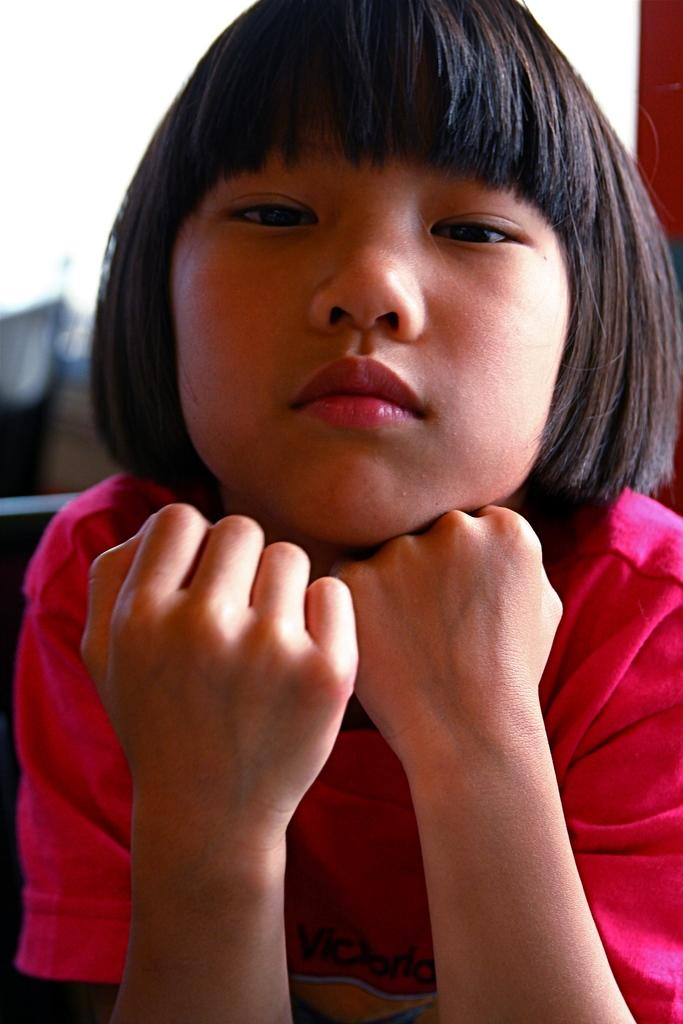Who is the main subject in the image? There is a girl in the image. What color are the clothes the girl is wearing? The girl is wearing pink clothes. Can you describe the background of the image? The background of the image is blurred. What type of paint is the girl using in the image? There is no paint or painting activity present in the image. 